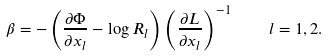Convert formula to latex. <formula><loc_0><loc_0><loc_500><loc_500>\beta = - \left ( \frac { \partial \Phi } { \partial x _ { l } } - \log R _ { l } \right ) \left ( \frac { \partial L } { \partial x _ { l } } \right ) ^ { - 1 } \quad l = 1 , 2 .</formula> 